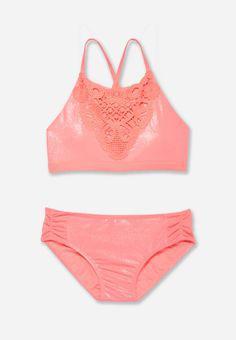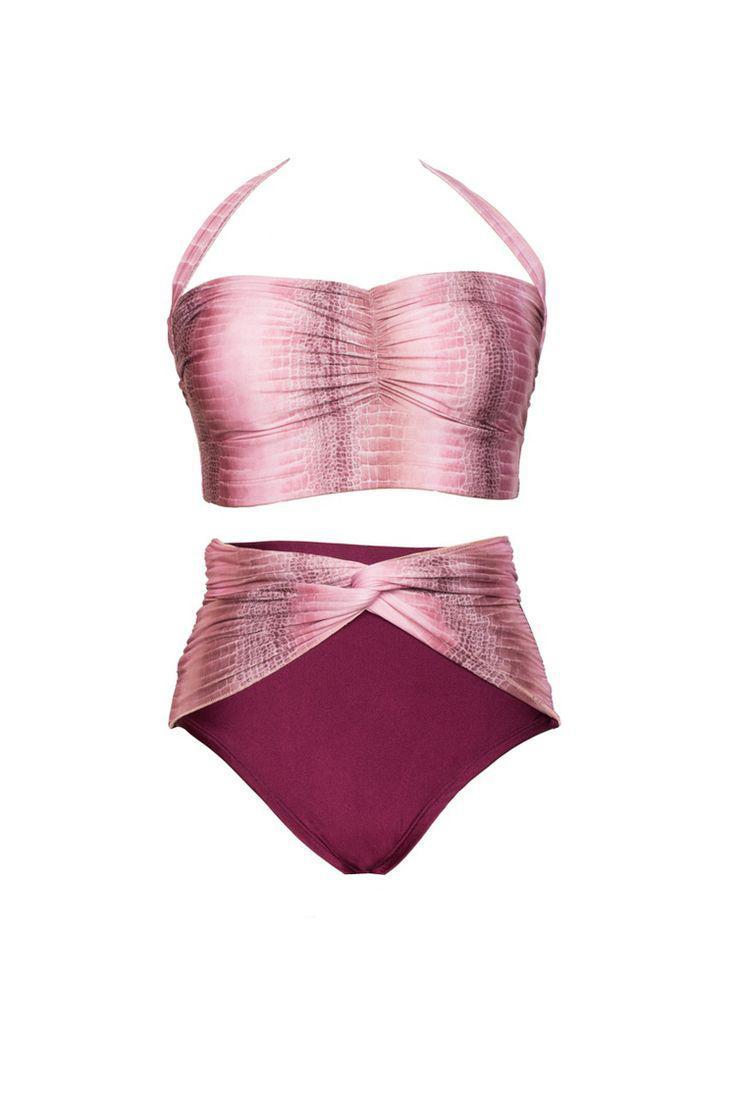The first image is the image on the left, the second image is the image on the right. Assess this claim about the two images: "There is not less than one mannequin". Correct or not? Answer yes or no. No. 